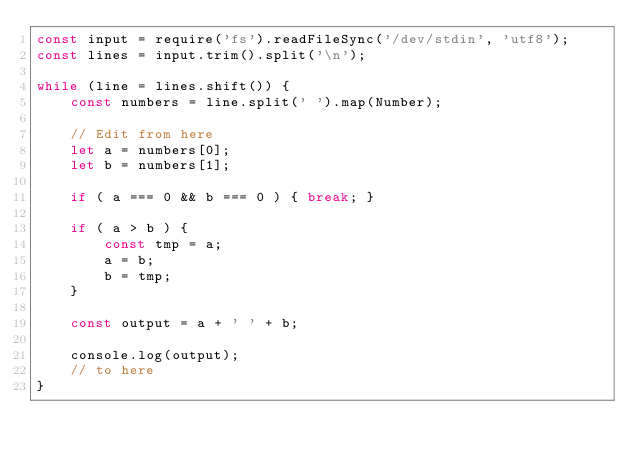Convert code to text. <code><loc_0><loc_0><loc_500><loc_500><_JavaScript_>const input = require('fs').readFileSync('/dev/stdin', 'utf8');
const lines = input.trim().split('\n');

while (line = lines.shift()) {
    const numbers = line.split(' ').map(Number);

    // Edit from here
    let a = numbers[0];
    let b = numbers[1];

    if ( a === 0 && b === 0 ) { break; }

    if ( a > b ) {
        const tmp = a;
        a = b;
        b = tmp;
    } 

    const output = a + ' ' + b;
    
    console.log(output);
    // to here
}

</code> 